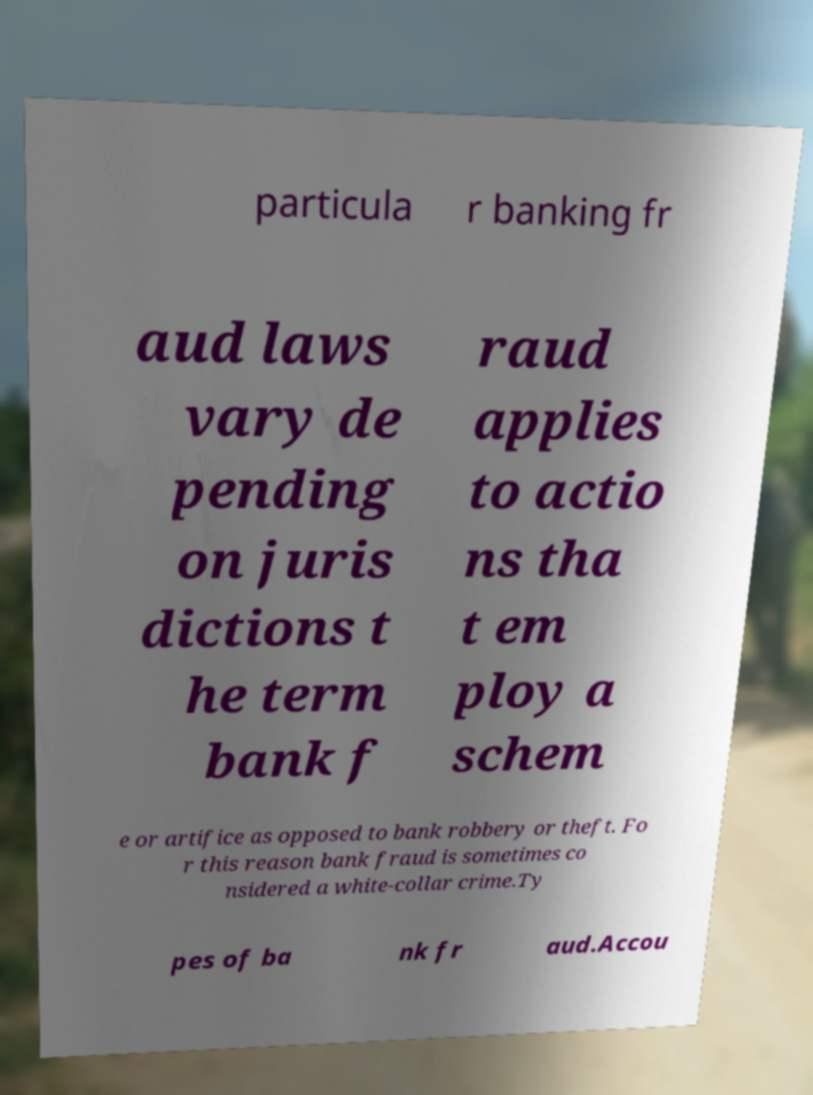Could you extract and type out the text from this image? particula r banking fr aud laws vary de pending on juris dictions t he term bank f raud applies to actio ns tha t em ploy a schem e or artifice as opposed to bank robbery or theft. Fo r this reason bank fraud is sometimes co nsidered a white-collar crime.Ty pes of ba nk fr aud.Accou 